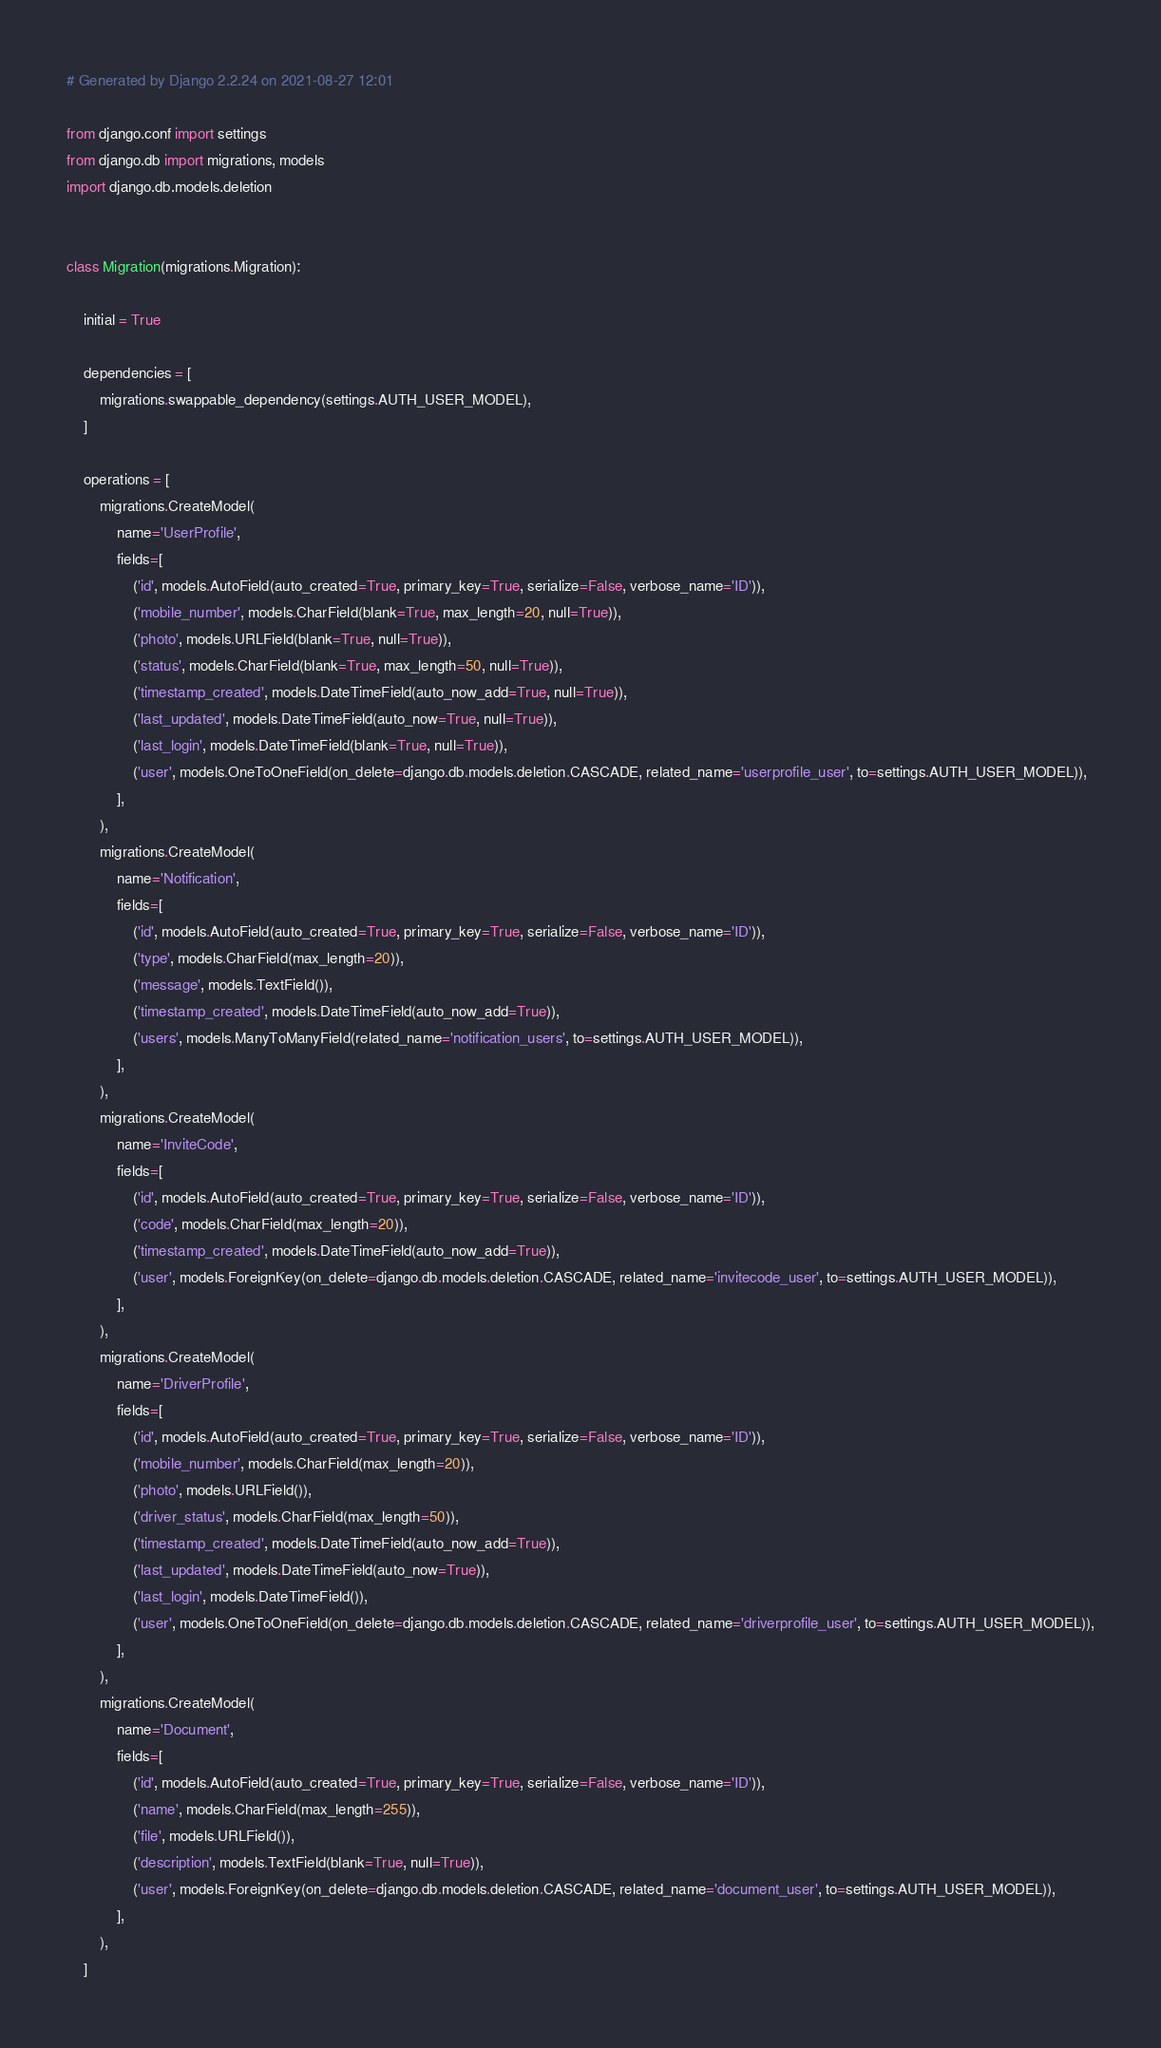<code> <loc_0><loc_0><loc_500><loc_500><_Python_># Generated by Django 2.2.24 on 2021-08-27 12:01

from django.conf import settings
from django.db import migrations, models
import django.db.models.deletion


class Migration(migrations.Migration):

    initial = True

    dependencies = [
        migrations.swappable_dependency(settings.AUTH_USER_MODEL),
    ]

    operations = [
        migrations.CreateModel(
            name='UserProfile',
            fields=[
                ('id', models.AutoField(auto_created=True, primary_key=True, serialize=False, verbose_name='ID')),
                ('mobile_number', models.CharField(blank=True, max_length=20, null=True)),
                ('photo', models.URLField(blank=True, null=True)),
                ('status', models.CharField(blank=True, max_length=50, null=True)),
                ('timestamp_created', models.DateTimeField(auto_now_add=True, null=True)),
                ('last_updated', models.DateTimeField(auto_now=True, null=True)),
                ('last_login', models.DateTimeField(blank=True, null=True)),
                ('user', models.OneToOneField(on_delete=django.db.models.deletion.CASCADE, related_name='userprofile_user', to=settings.AUTH_USER_MODEL)),
            ],
        ),
        migrations.CreateModel(
            name='Notification',
            fields=[
                ('id', models.AutoField(auto_created=True, primary_key=True, serialize=False, verbose_name='ID')),
                ('type', models.CharField(max_length=20)),
                ('message', models.TextField()),
                ('timestamp_created', models.DateTimeField(auto_now_add=True)),
                ('users', models.ManyToManyField(related_name='notification_users', to=settings.AUTH_USER_MODEL)),
            ],
        ),
        migrations.CreateModel(
            name='InviteCode',
            fields=[
                ('id', models.AutoField(auto_created=True, primary_key=True, serialize=False, verbose_name='ID')),
                ('code', models.CharField(max_length=20)),
                ('timestamp_created', models.DateTimeField(auto_now_add=True)),
                ('user', models.ForeignKey(on_delete=django.db.models.deletion.CASCADE, related_name='invitecode_user', to=settings.AUTH_USER_MODEL)),
            ],
        ),
        migrations.CreateModel(
            name='DriverProfile',
            fields=[
                ('id', models.AutoField(auto_created=True, primary_key=True, serialize=False, verbose_name='ID')),
                ('mobile_number', models.CharField(max_length=20)),
                ('photo', models.URLField()),
                ('driver_status', models.CharField(max_length=50)),
                ('timestamp_created', models.DateTimeField(auto_now_add=True)),
                ('last_updated', models.DateTimeField(auto_now=True)),
                ('last_login', models.DateTimeField()),
                ('user', models.OneToOneField(on_delete=django.db.models.deletion.CASCADE, related_name='driverprofile_user', to=settings.AUTH_USER_MODEL)),
            ],
        ),
        migrations.CreateModel(
            name='Document',
            fields=[
                ('id', models.AutoField(auto_created=True, primary_key=True, serialize=False, verbose_name='ID')),
                ('name', models.CharField(max_length=255)),
                ('file', models.URLField()),
                ('description', models.TextField(blank=True, null=True)),
                ('user', models.ForeignKey(on_delete=django.db.models.deletion.CASCADE, related_name='document_user', to=settings.AUTH_USER_MODEL)),
            ],
        ),
    ]
</code> 